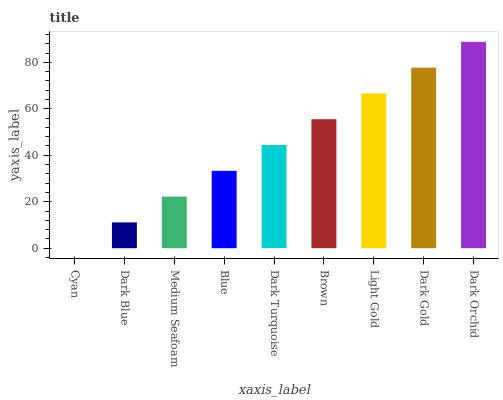Is Cyan the minimum?
Answer yes or no. Yes. Is Dark Orchid the maximum?
Answer yes or no. Yes. Is Dark Blue the minimum?
Answer yes or no. No. Is Dark Blue the maximum?
Answer yes or no. No. Is Dark Blue greater than Cyan?
Answer yes or no. Yes. Is Cyan less than Dark Blue?
Answer yes or no. Yes. Is Cyan greater than Dark Blue?
Answer yes or no. No. Is Dark Blue less than Cyan?
Answer yes or no. No. Is Dark Turquoise the high median?
Answer yes or no. Yes. Is Dark Turquoise the low median?
Answer yes or no. Yes. Is Cyan the high median?
Answer yes or no. No. Is Brown the low median?
Answer yes or no. No. 